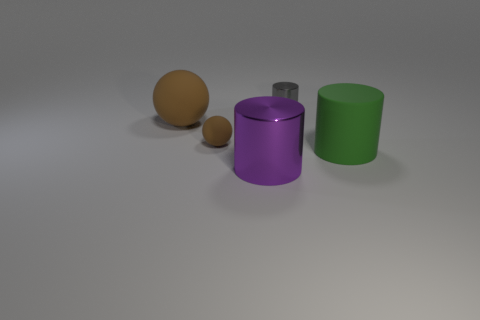Add 3 purple cylinders. How many objects exist? 8 Subtract all spheres. How many objects are left? 3 Subtract all green cylinders. Subtract all large shiny cylinders. How many objects are left? 3 Add 1 brown things. How many brown things are left? 3 Add 3 small yellow shiny cylinders. How many small yellow shiny cylinders exist? 3 Subtract 0 green spheres. How many objects are left? 5 